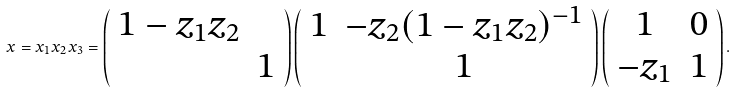<formula> <loc_0><loc_0><loc_500><loc_500>x = x _ { 1 } x _ { 2 } x _ { 3 } = \left ( \begin{array} { c c } 1 - z _ { 1 } z _ { 2 } & \\ & 1 \end{array} \right ) \left ( \begin{array} { c c } 1 & - z _ { 2 } ( 1 - z _ { 1 } z _ { 2 } ) ^ { - 1 } \\ & 1 \end{array} \right ) \left ( \begin{array} { c c } 1 & 0 \\ - z _ { 1 } & 1 \end{array} \right ) .</formula> 